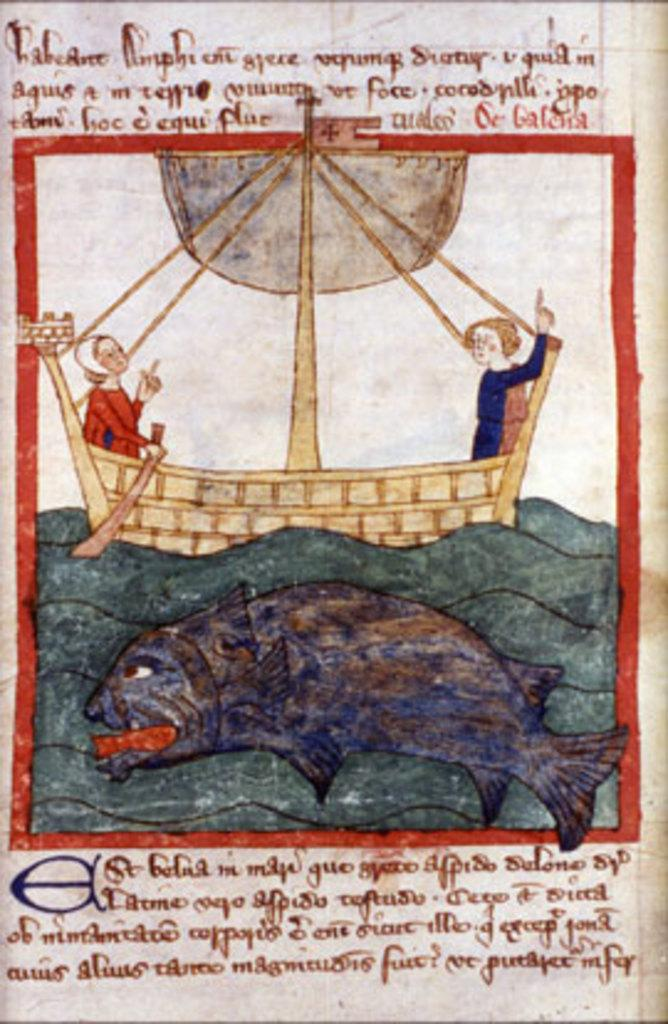What is the main subject of the picture? The main subject of the picture is an image. Can you describe the image in the picture? Unfortunately, the facts provided do not give any details about the image itself. What else can be seen in the picture besides the image? There is text printed on a paper in the picture. What type of flower is growing on the cast in the picture? There is no cast or flower present in the picture; it only contains an image and text printed on a paper. 